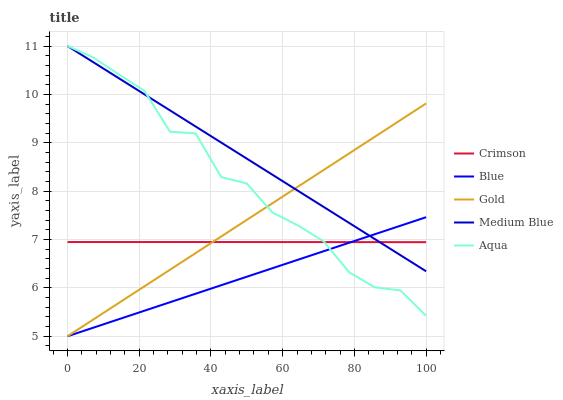Does Blue have the minimum area under the curve?
Answer yes or no. Yes. Does Medium Blue have the maximum area under the curve?
Answer yes or no. Yes. Does Aqua have the minimum area under the curve?
Answer yes or no. No. Does Aqua have the maximum area under the curve?
Answer yes or no. No. Is Medium Blue the smoothest?
Answer yes or no. Yes. Is Aqua the roughest?
Answer yes or no. Yes. Is Blue the smoothest?
Answer yes or no. No. Is Blue the roughest?
Answer yes or no. No. Does Blue have the lowest value?
Answer yes or no. Yes. Does Aqua have the lowest value?
Answer yes or no. No. Does Medium Blue have the highest value?
Answer yes or no. Yes. Does Blue have the highest value?
Answer yes or no. No. Does Medium Blue intersect Blue?
Answer yes or no. Yes. Is Medium Blue less than Blue?
Answer yes or no. No. Is Medium Blue greater than Blue?
Answer yes or no. No. 